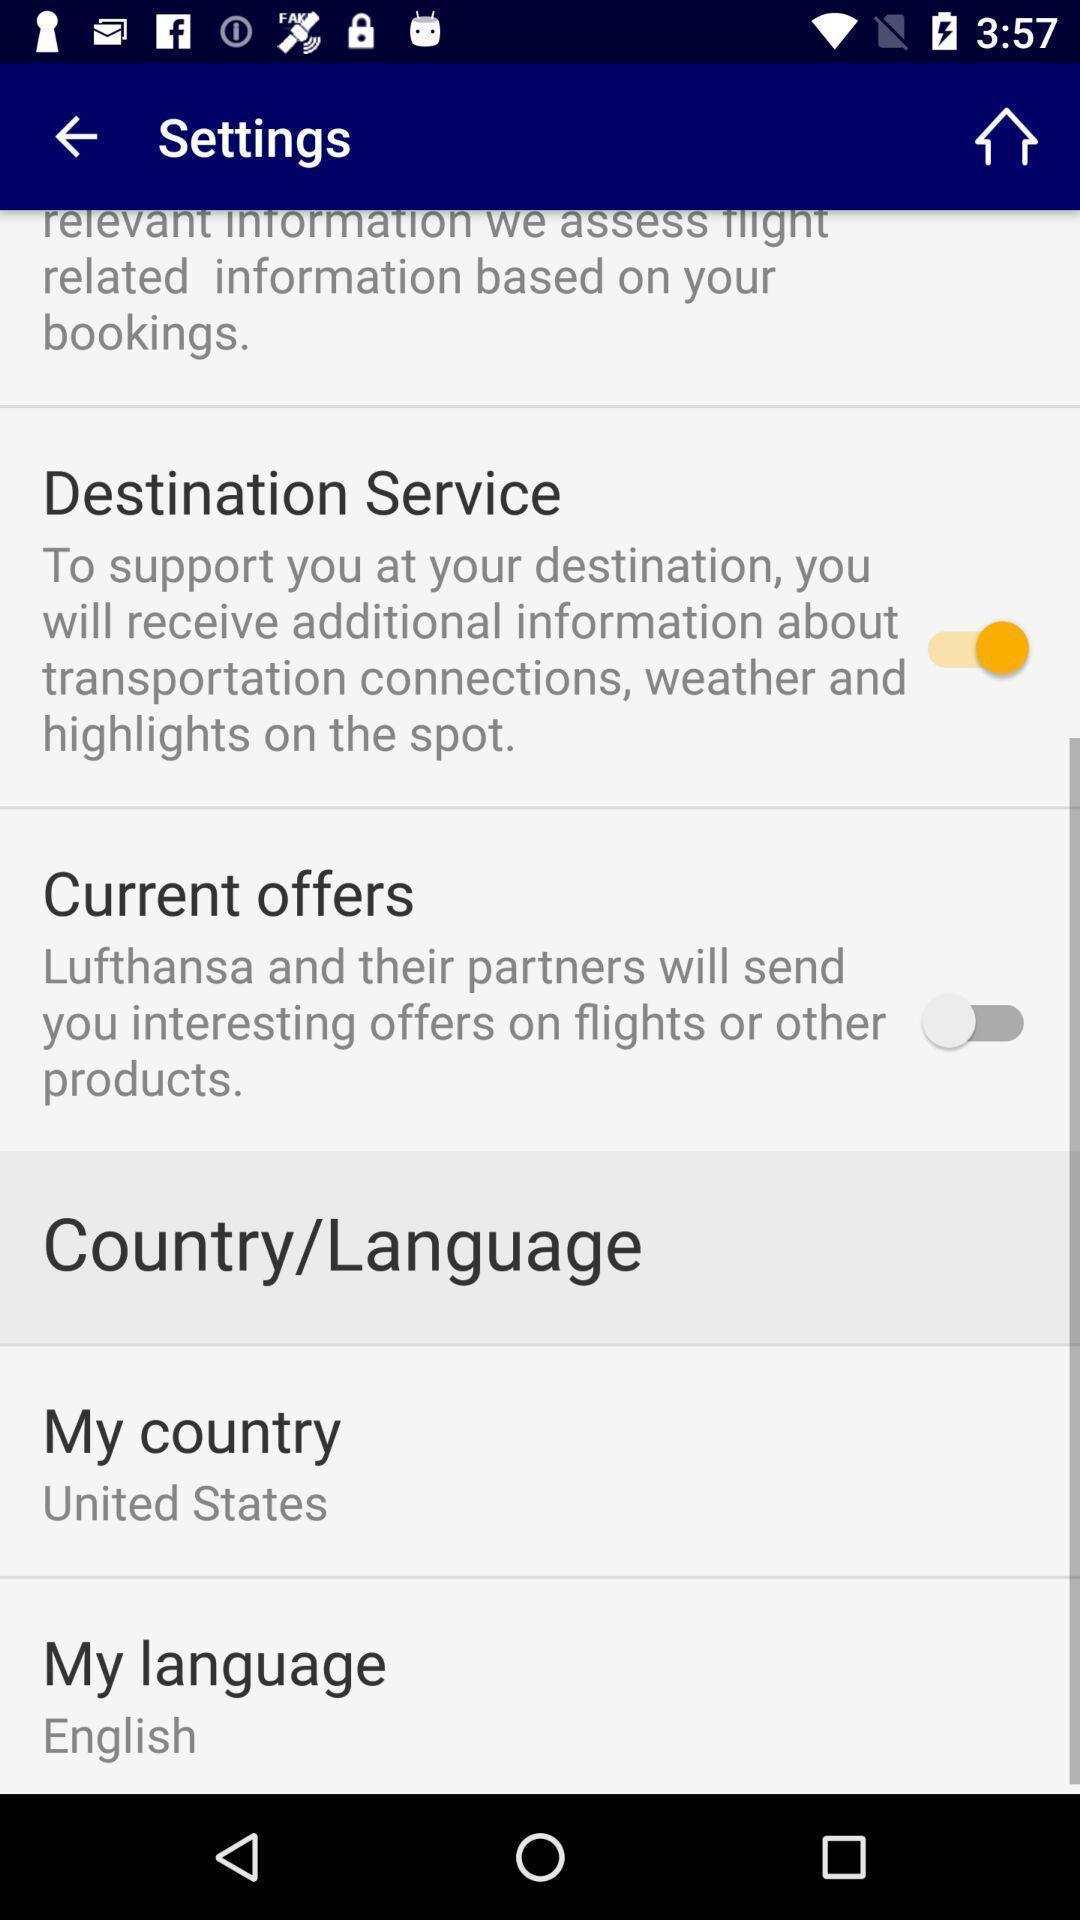What is the overall content of this screenshot? Settings page. 